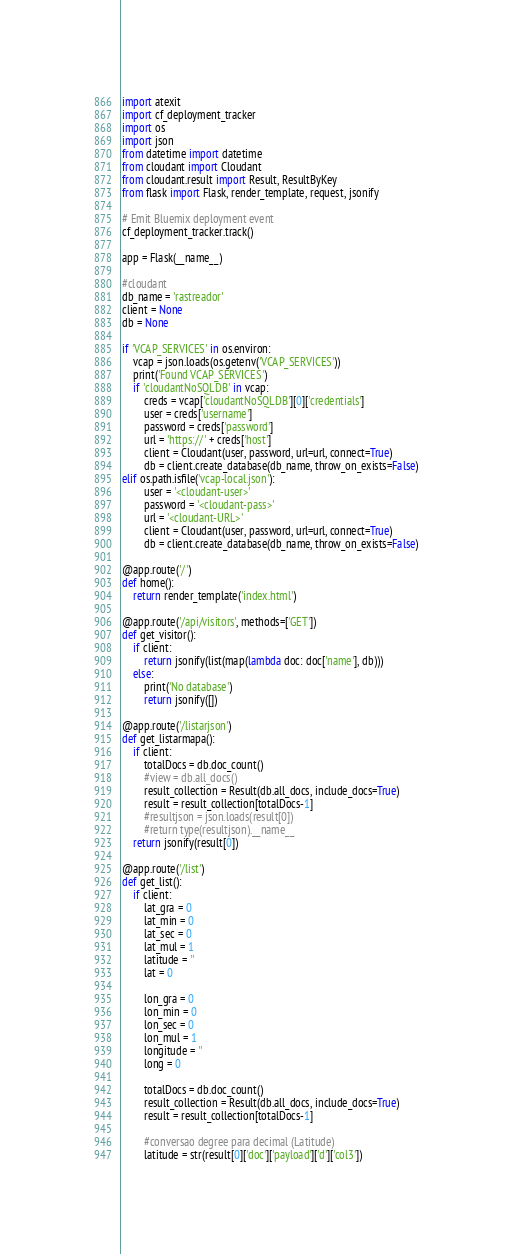Convert code to text. <code><loc_0><loc_0><loc_500><loc_500><_Python_>import atexit
import cf_deployment_tracker
import os
import json
from datetime import datetime
from cloudant import Cloudant
from cloudant.result import Result, ResultByKey
from flask import Flask, render_template, request, jsonify

# Emit Bluemix deployment event
cf_deployment_tracker.track()

app = Flask(__name__)

#cloudant
db_name = 'rastreador'
client = None
db = None

if 'VCAP_SERVICES' in os.environ:
    vcap = json.loads(os.getenv('VCAP_SERVICES'))
    print('Found VCAP_SERVICES')
    if 'cloudantNoSQLDB' in vcap:
        creds = vcap['cloudantNoSQLDB'][0]['credentials']
        user = creds['username']
        password = creds['password']
        url = 'https://' + creds['host']
        client = Cloudant(user, password, url=url, connect=True)
        db = client.create_database(db_name, throw_on_exists=False)
elif os.path.isfile('vcap-local.json'):
        user = '<cloudant-user>'
        password = '<cloudant-pass>'
        url = '<cloudant-URL>'
        client = Cloudant(user, password, url=url, connect=True)
        db = client.create_database(db_name, throw_on_exists=False)

@app.route('/')
def home():
    return render_template('index.html')

@app.route('/api/visitors', methods=['GET'])
def get_visitor():
    if client:
        return jsonify(list(map(lambda doc: doc['name'], db)))
    else:
        print('No database')
        return jsonify([])

@app.route('/listarjson')
def get_listarmapa():
	if client:
		totalDocs = db.doc_count()
        #view = db.all_docs()
		result_collection = Result(db.all_docs, include_docs=True)
		result = result_collection[totalDocs-1]
        #resultjson = json.loads(result[0])
	    #return type(resultjson).__name__
	return jsonify(result[0])

@app.route('/list')
def get_list():
    if client:
        lat_gra = 0
        lat_min = 0
        lat_sec = 0
        lat_mul = 1
        latitude = ''
        lat = 0

        lon_gra = 0
        lon_min = 0
        lon_sec = 0
        lon_mul = 1
        longitude = ''
        long = 0

        totalDocs = db.doc_count()
        result_collection = Result(db.all_docs, include_docs=True)
        result = result_collection[totalDocs-1]

        #conversao degree para decimal (Latitude)
        latitude = str(result[0]['doc']['payload']['d']['col3'])</code> 